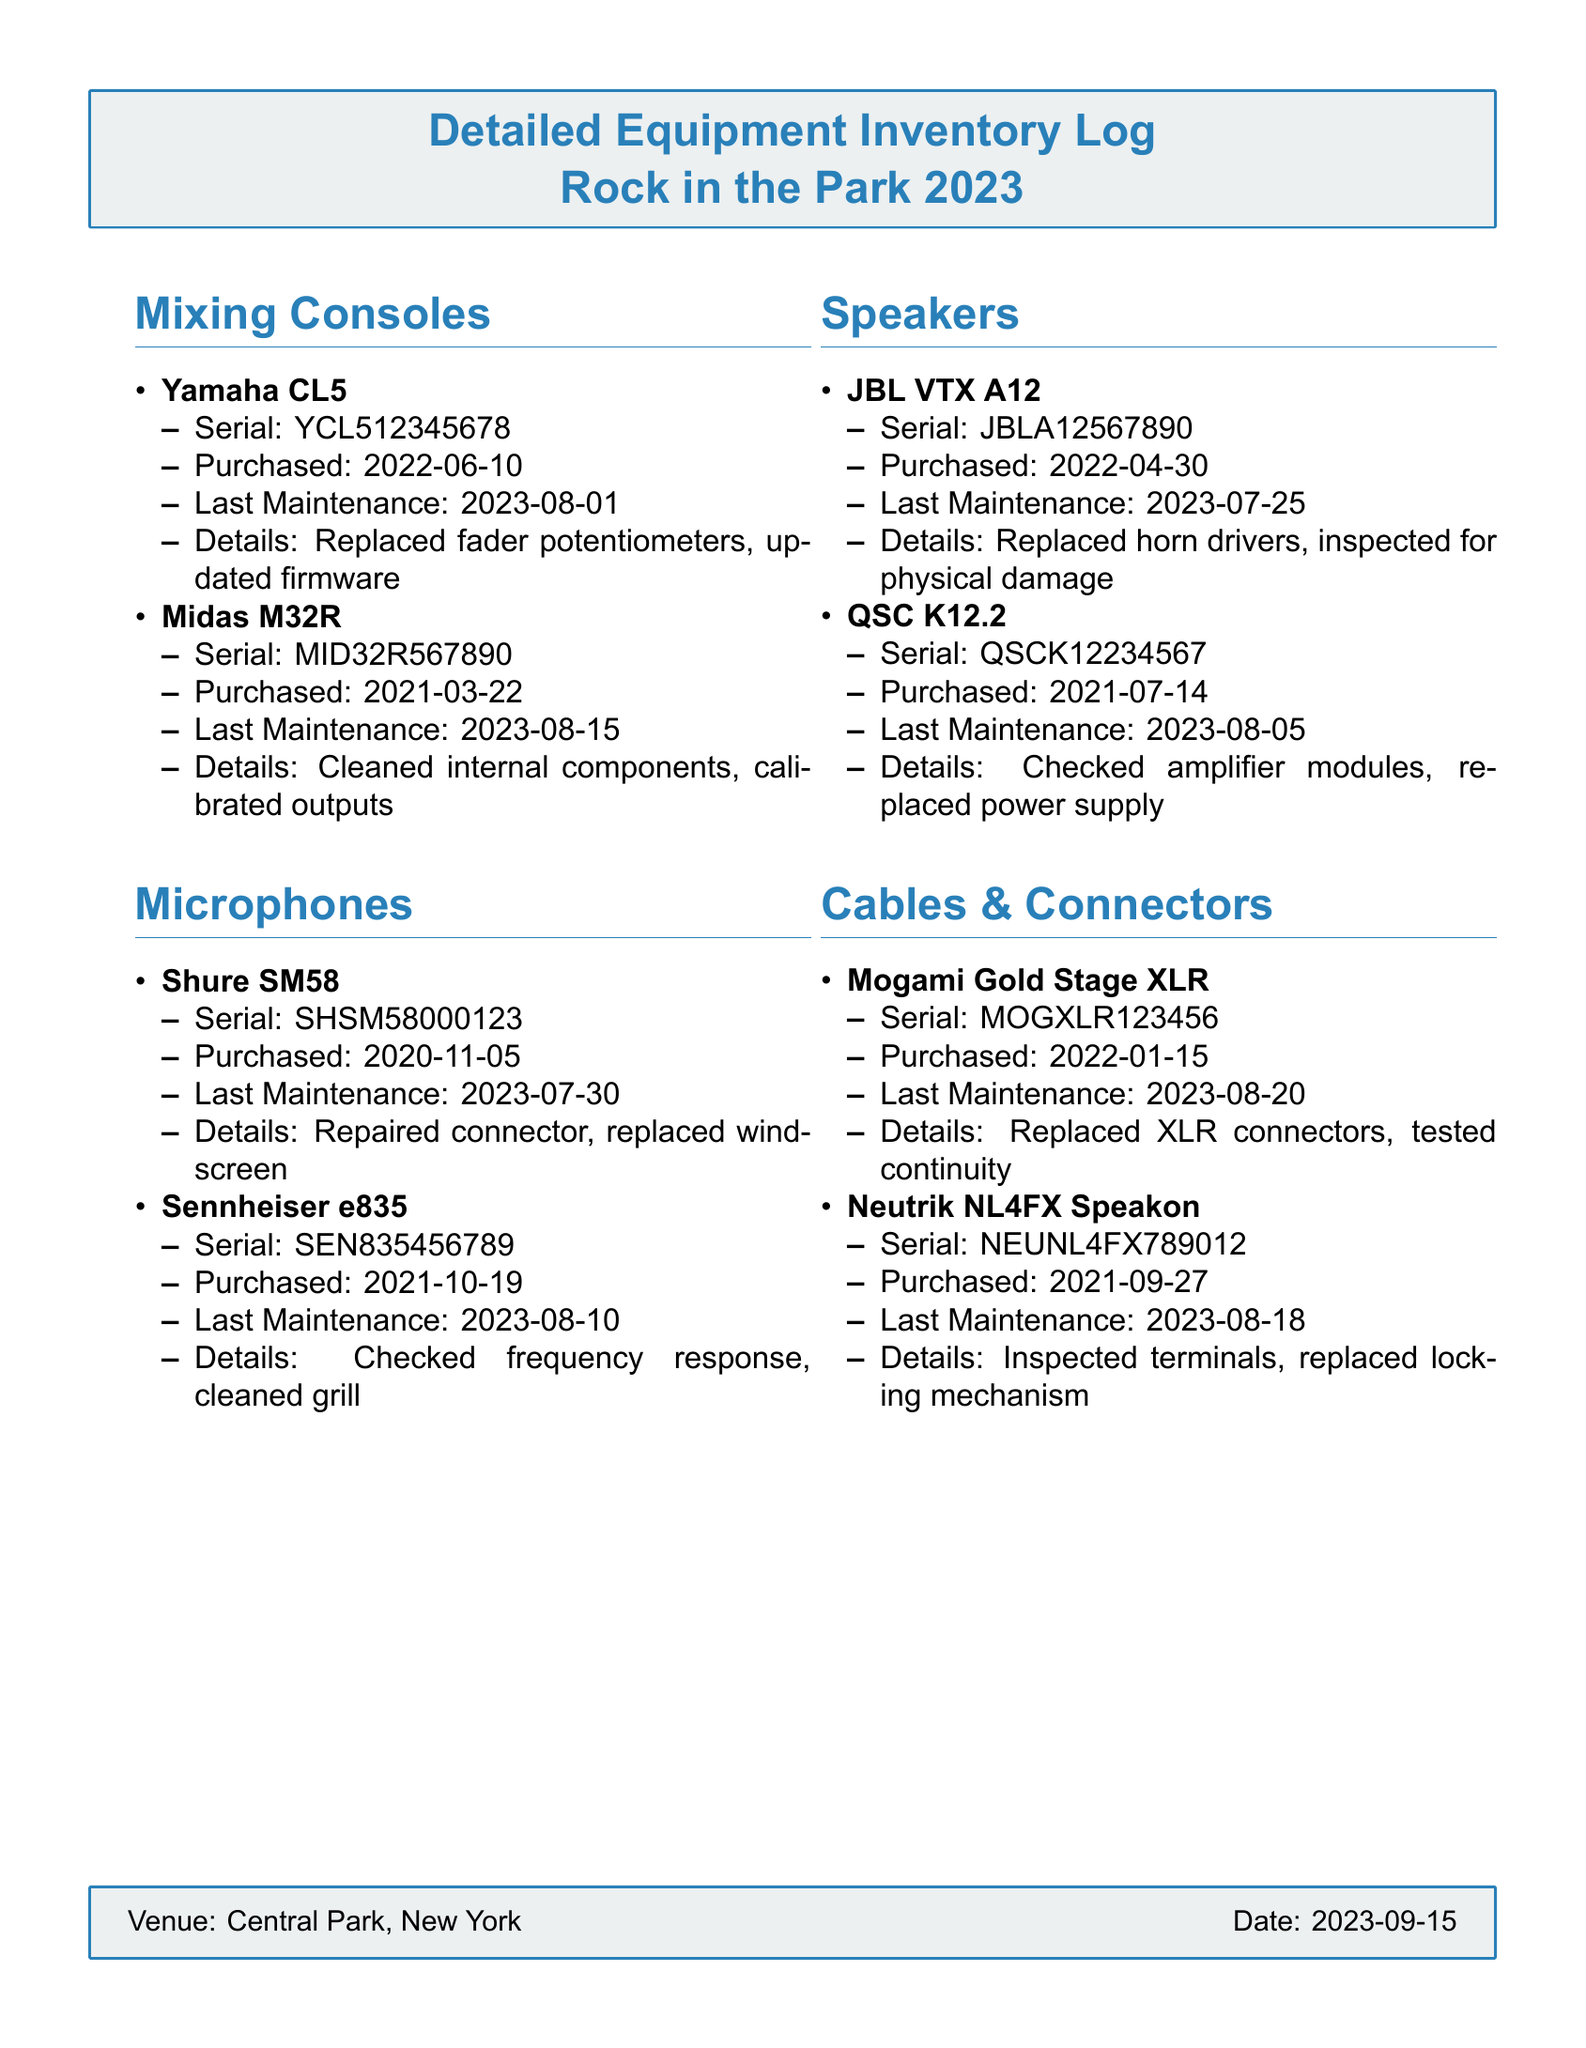what is the model of the Yamaha mixing console? The model of the Yamaha mixing console listed in the document is CL5.
Answer: CL5 when was the last maintenance for the Sennheiser microphone? The last maintenance date for the Sennheiser microphone is shown in the document as 2023-08-10.
Answer: 2023-08-10 how many speakers are mentioned in the inventory log? There are two speakers listed in the inventory log: JBL VTX A12 and QSC K12.2.
Answer: 2 which cable brand had its XLR connectors replaced? The brand of the cable that had its XLR connectors replaced, as stated in the document, is Mogami.
Answer: Mogami what maintenance was performed on the Midas M32R? The maintenance performed on the Midas M32R included cleaning internal components and calibrating outputs.
Answer: Cleaned internal components, calibrated outputs which equipment item was purchased on 2022-04-30? The equipment item purchased on 2022-04-30 is the JBL VTX A12 speaker.
Answer: JBL VTX A12 when did the last maintenance occur for the Mogami cable? The last maintenance for the Mogami cable occurred on 2023-08-20.
Answer: 2023-08-20 what details are provided about the Shure SM58 microphone? The details provided include repaired connector and replaced windscreen.
Answer: Repaired connector, replaced windscreen 